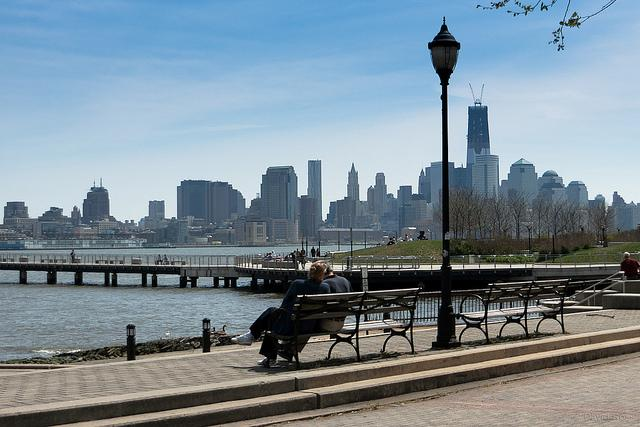Who is this area designed for?

Choices:
A) employees
B) public
C) customers
D) politicians public 